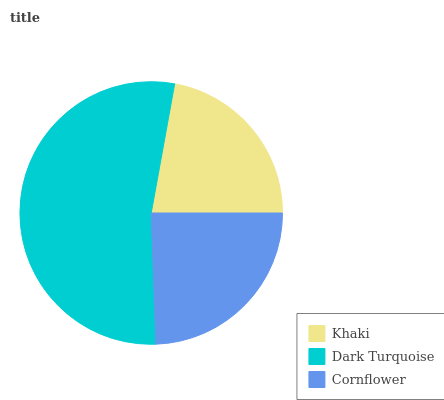Is Khaki the minimum?
Answer yes or no. Yes. Is Dark Turquoise the maximum?
Answer yes or no. Yes. Is Cornflower the minimum?
Answer yes or no. No. Is Cornflower the maximum?
Answer yes or no. No. Is Dark Turquoise greater than Cornflower?
Answer yes or no. Yes. Is Cornflower less than Dark Turquoise?
Answer yes or no. Yes. Is Cornflower greater than Dark Turquoise?
Answer yes or no. No. Is Dark Turquoise less than Cornflower?
Answer yes or no. No. Is Cornflower the high median?
Answer yes or no. Yes. Is Cornflower the low median?
Answer yes or no. Yes. Is Khaki the high median?
Answer yes or no. No. Is Khaki the low median?
Answer yes or no. No. 